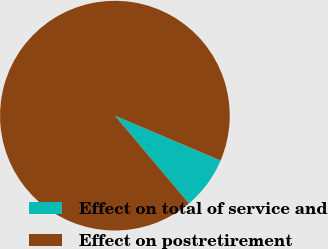Convert chart to OTSL. <chart><loc_0><loc_0><loc_500><loc_500><pie_chart><fcel>Effect on total of service and<fcel>Effect on postretirement<nl><fcel>7.46%<fcel>92.54%<nl></chart> 